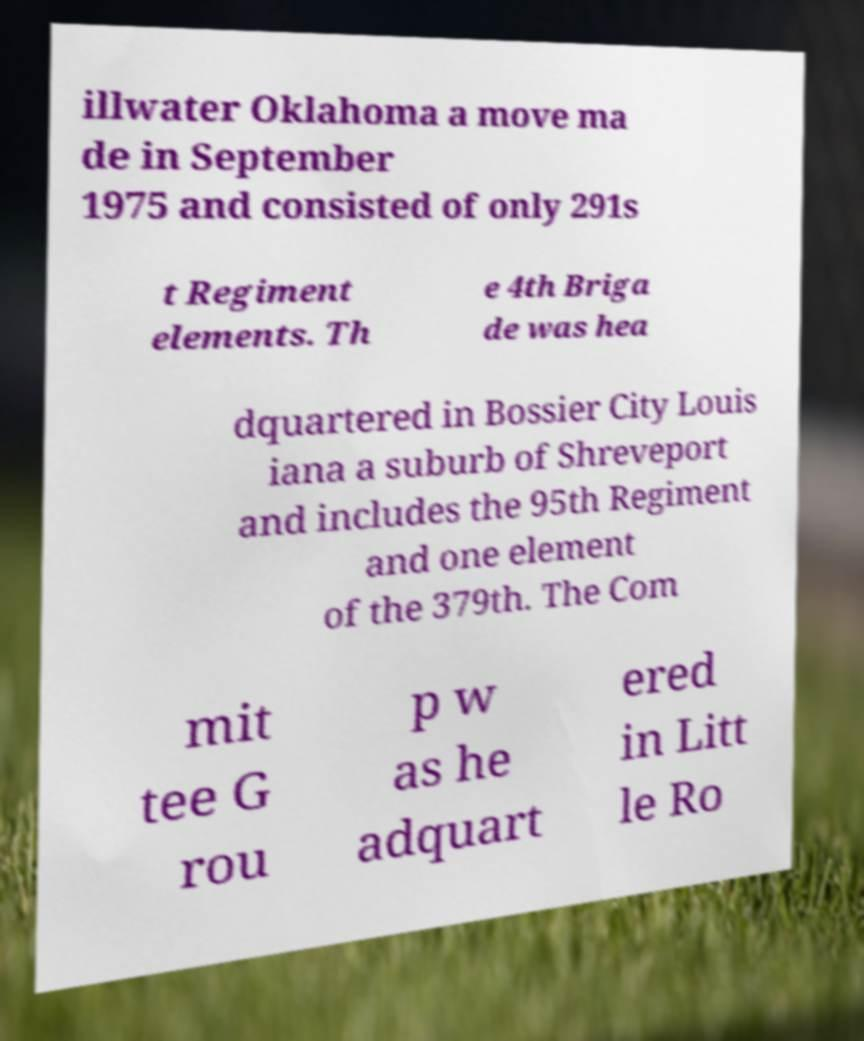What messages or text are displayed in this image? I need them in a readable, typed format. illwater Oklahoma a move ma de in September 1975 and consisted of only 291s t Regiment elements. Th e 4th Briga de was hea dquartered in Bossier City Louis iana a suburb of Shreveport and includes the 95th Regiment and one element of the 379th. The Com mit tee G rou p w as he adquart ered in Litt le Ro 